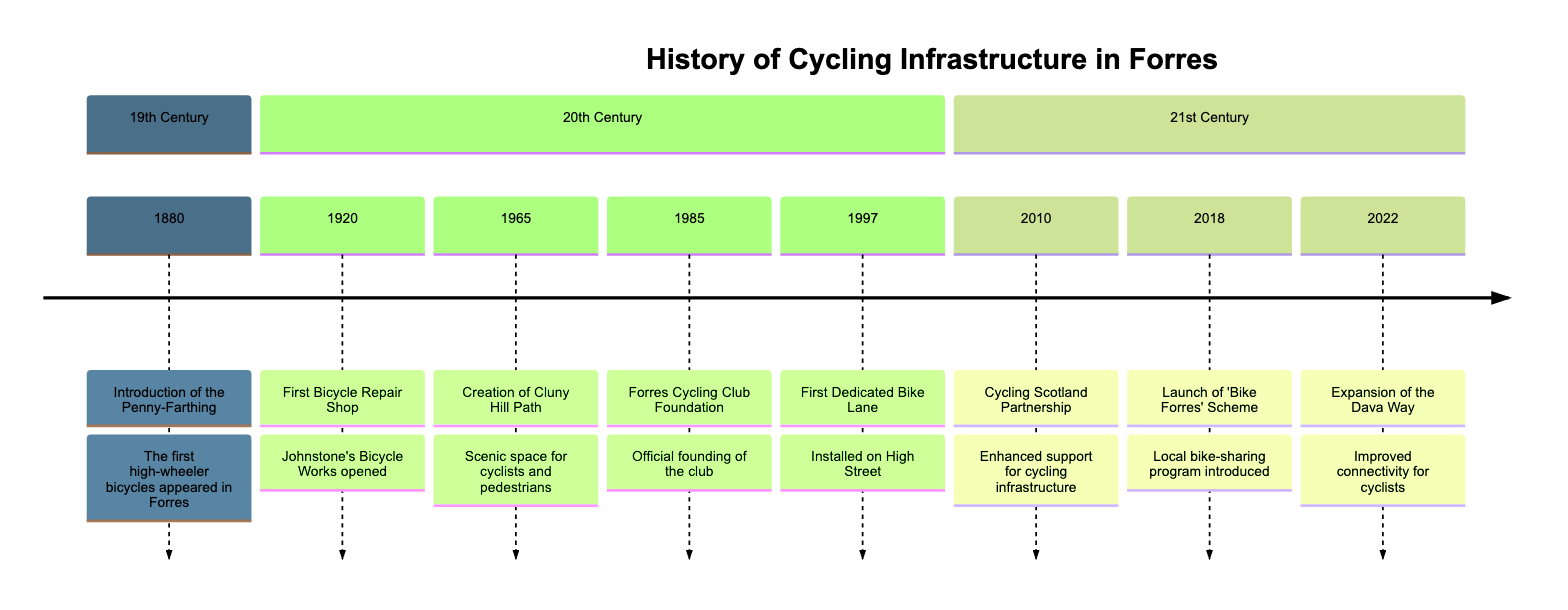What year did the first bicycle repair shop open? According to the timeline, the first bicycle repair shop, Johnstone's Bicycle Works, opened in 1920. This is explicitly stated as part of the event description.
Answer: 1920 What event occurred in 2010? The timeline shows that in 2010, the event was the Cycling Scotland Partnership. This is directly indicated in the corresponding node.
Answer: Cycling Scotland Partnership How many events are listed in the 20th century? The timeline specifies four distinct events that occurred during the 20th century: the first bicycle repair shop in 1920, the creation of Cluny Hill Path in 1965, the founding of the Forres Cycling Club in 1985, and the first dedicated bike lane installed in 1997. By counting these events, we arrive at the number.
Answer: 4 What was established in 1985? The year 1985 on the timeline denotes the founding of the Forres Cycling Club. This is a significant community event aimed at promoting cycling.
Answer: Forres Cycling Club Which infrastructure was expanded in 2022? The timeline indicates that in 2022, the Dava Way cycle path was expanded. This detail is part of the specific event description for that year.
Answer: Dava Way What was the purpose of the 'Bike Forres' Scheme launched in 2018? The timeline describes the 'Bike Forres' Scheme as a local bike-sharing and community program aimed at encouraging cycling among all age groups. This captures the scheme's intent succinctly.
Answer: Encourage cycling Which event reflects a partnership for cycling support? The specific event of the Cycling Scotland Partnership in 2010 reflects a partnership aimed at enhancing support for cycling infrastructure improvements. This partnership is highlighted in the event description provided.
Answer: Cycling Scotland Partnership Which two events are most closely related to the bicycle infrastructure's expansion? The events from 2010 (Cycling Scotland Partnership) and 2022 (Expansion of the Dava Way) are most closely related to the overall expansion and support of cycling infrastructure in Forres. Both address infrastructure development, with time progression.
Answer: 2010 and 2022 What type of bike was introduced in Forres in 1880? The timeline indicates that the Penny-Farthing, a type of high-wheeler bicycle, was introduced in Forres in 1880, marking the initiation of cycling in the town.
Answer: Penny-Farthing 